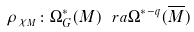<formula> <loc_0><loc_0><loc_500><loc_500>\rho _ { \chi _ { M } } \colon \Omega ^ { * } _ { G } ( M ) \ r a \Omega ^ { * - q } ( \overline { M } )</formula> 